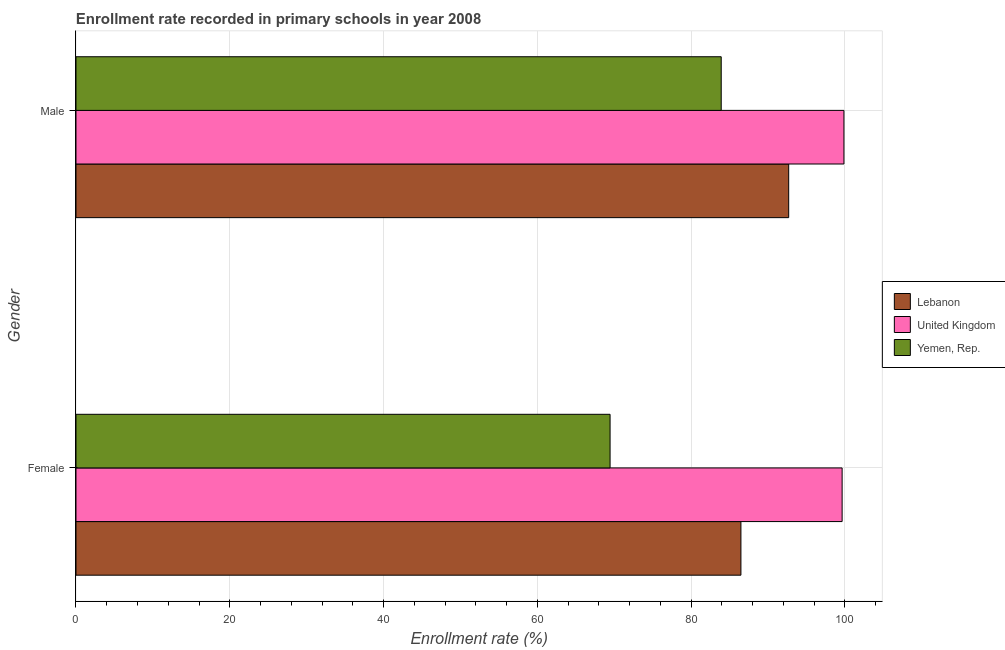How many different coloured bars are there?
Your response must be concise. 3. Are the number of bars per tick equal to the number of legend labels?
Keep it short and to the point. Yes. What is the label of the 1st group of bars from the top?
Give a very brief answer. Male. What is the enrollment rate of male students in Lebanon?
Provide a succinct answer. 92.69. Across all countries, what is the maximum enrollment rate of female students?
Your response must be concise. 99.64. Across all countries, what is the minimum enrollment rate of male students?
Give a very brief answer. 83.92. In which country was the enrollment rate of female students minimum?
Provide a short and direct response. Yemen, Rep. What is the total enrollment rate of female students in the graph?
Offer a terse response. 255.58. What is the difference between the enrollment rate of male students in Lebanon and that in Yemen, Rep.?
Your answer should be very brief. 8.78. What is the difference between the enrollment rate of female students in Lebanon and the enrollment rate of male students in United Kingdom?
Ensure brevity in your answer.  -13.4. What is the average enrollment rate of female students per country?
Make the answer very short. 85.19. What is the difference between the enrollment rate of female students and enrollment rate of male students in Yemen, Rep.?
Offer a very short reply. -14.45. What is the ratio of the enrollment rate of female students in United Kingdom to that in Lebanon?
Your answer should be compact. 1.15. What does the 3rd bar from the top in Male represents?
Provide a succinct answer. Lebanon. What does the 2nd bar from the bottom in Female represents?
Offer a terse response. United Kingdom. How many bars are there?
Give a very brief answer. 6. Does the graph contain any zero values?
Offer a very short reply. No. Does the graph contain grids?
Your answer should be compact. Yes. Where does the legend appear in the graph?
Make the answer very short. Center right. What is the title of the graph?
Your response must be concise. Enrollment rate recorded in primary schools in year 2008. Does "Lao PDR" appear as one of the legend labels in the graph?
Ensure brevity in your answer.  No. What is the label or title of the X-axis?
Your answer should be compact. Enrollment rate (%). What is the Enrollment rate (%) in Lebanon in Female?
Give a very brief answer. 86.48. What is the Enrollment rate (%) of United Kingdom in Female?
Your answer should be very brief. 99.64. What is the Enrollment rate (%) in Yemen, Rep. in Female?
Your response must be concise. 69.46. What is the Enrollment rate (%) of Lebanon in Male?
Make the answer very short. 92.69. What is the Enrollment rate (%) of United Kingdom in Male?
Make the answer very short. 99.88. What is the Enrollment rate (%) of Yemen, Rep. in Male?
Your response must be concise. 83.92. Across all Gender, what is the maximum Enrollment rate (%) in Lebanon?
Your answer should be very brief. 92.69. Across all Gender, what is the maximum Enrollment rate (%) of United Kingdom?
Give a very brief answer. 99.88. Across all Gender, what is the maximum Enrollment rate (%) in Yemen, Rep.?
Offer a terse response. 83.92. Across all Gender, what is the minimum Enrollment rate (%) in Lebanon?
Offer a terse response. 86.48. Across all Gender, what is the minimum Enrollment rate (%) of United Kingdom?
Your response must be concise. 99.64. Across all Gender, what is the minimum Enrollment rate (%) of Yemen, Rep.?
Provide a short and direct response. 69.46. What is the total Enrollment rate (%) in Lebanon in the graph?
Ensure brevity in your answer.  179.17. What is the total Enrollment rate (%) in United Kingdom in the graph?
Your answer should be very brief. 199.52. What is the total Enrollment rate (%) in Yemen, Rep. in the graph?
Provide a short and direct response. 153.38. What is the difference between the Enrollment rate (%) in Lebanon in Female and that in Male?
Keep it short and to the point. -6.21. What is the difference between the Enrollment rate (%) in United Kingdom in Female and that in Male?
Provide a succinct answer. -0.24. What is the difference between the Enrollment rate (%) of Yemen, Rep. in Female and that in Male?
Your answer should be very brief. -14.45. What is the difference between the Enrollment rate (%) of Lebanon in Female and the Enrollment rate (%) of United Kingdom in Male?
Your answer should be very brief. -13.4. What is the difference between the Enrollment rate (%) in Lebanon in Female and the Enrollment rate (%) in Yemen, Rep. in Male?
Offer a very short reply. 2.56. What is the difference between the Enrollment rate (%) in United Kingdom in Female and the Enrollment rate (%) in Yemen, Rep. in Male?
Your answer should be very brief. 15.73. What is the average Enrollment rate (%) of Lebanon per Gender?
Offer a very short reply. 89.58. What is the average Enrollment rate (%) of United Kingdom per Gender?
Provide a succinct answer. 99.76. What is the average Enrollment rate (%) of Yemen, Rep. per Gender?
Provide a succinct answer. 76.69. What is the difference between the Enrollment rate (%) in Lebanon and Enrollment rate (%) in United Kingdom in Female?
Offer a terse response. -13.16. What is the difference between the Enrollment rate (%) of Lebanon and Enrollment rate (%) of Yemen, Rep. in Female?
Your response must be concise. 17.02. What is the difference between the Enrollment rate (%) of United Kingdom and Enrollment rate (%) of Yemen, Rep. in Female?
Your answer should be compact. 30.18. What is the difference between the Enrollment rate (%) of Lebanon and Enrollment rate (%) of United Kingdom in Male?
Give a very brief answer. -7.19. What is the difference between the Enrollment rate (%) of Lebanon and Enrollment rate (%) of Yemen, Rep. in Male?
Make the answer very short. 8.78. What is the difference between the Enrollment rate (%) of United Kingdom and Enrollment rate (%) of Yemen, Rep. in Male?
Keep it short and to the point. 15.96. What is the ratio of the Enrollment rate (%) of Lebanon in Female to that in Male?
Your response must be concise. 0.93. What is the ratio of the Enrollment rate (%) of Yemen, Rep. in Female to that in Male?
Your response must be concise. 0.83. What is the difference between the highest and the second highest Enrollment rate (%) of Lebanon?
Your response must be concise. 6.21. What is the difference between the highest and the second highest Enrollment rate (%) in United Kingdom?
Keep it short and to the point. 0.24. What is the difference between the highest and the second highest Enrollment rate (%) of Yemen, Rep.?
Your answer should be very brief. 14.45. What is the difference between the highest and the lowest Enrollment rate (%) of Lebanon?
Your response must be concise. 6.21. What is the difference between the highest and the lowest Enrollment rate (%) of United Kingdom?
Provide a succinct answer. 0.24. What is the difference between the highest and the lowest Enrollment rate (%) in Yemen, Rep.?
Offer a terse response. 14.45. 